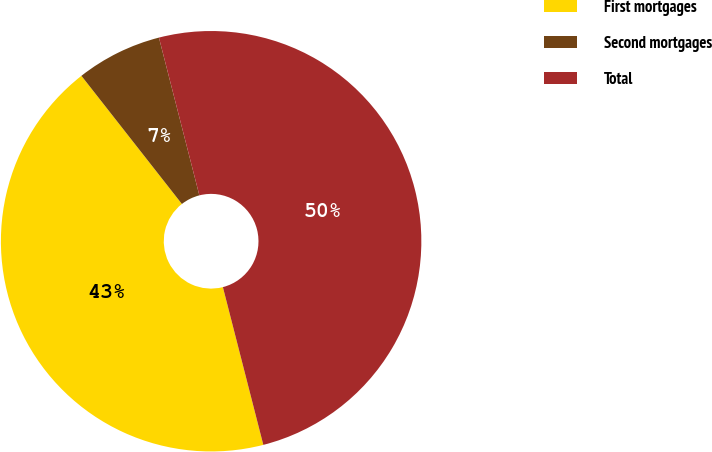Convert chart. <chart><loc_0><loc_0><loc_500><loc_500><pie_chart><fcel>First mortgages<fcel>Second mortgages<fcel>Total<nl><fcel>43.41%<fcel>6.59%<fcel>50.0%<nl></chart> 